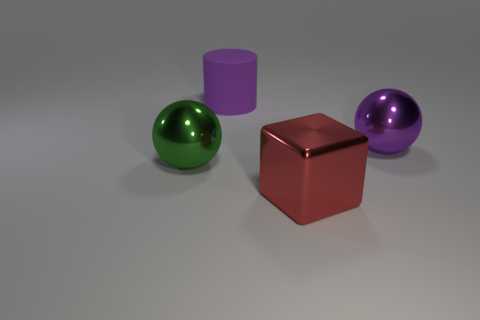Can you describe the lighting in the image? The image is lit by a diffuse light source that casts soft shadows and highlights, indicating the light source is not directly visible but rather spread out, possibly simulating an overcast day or studio lighting with softboxes. 